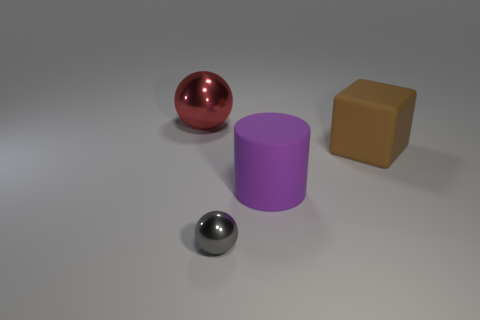What is the color of the metallic thing that is to the right of the shiny ball that is behind the rubber thing that is left of the rubber block?
Provide a succinct answer. Gray. What number of big cubes are the same color as the big metallic object?
Your answer should be compact. 0. What number of small things are red spheres or gray spheres?
Provide a short and direct response. 1. Is there a small metallic thing of the same shape as the big brown matte object?
Provide a short and direct response. No. Is the big red metallic object the same shape as the brown rubber thing?
Your answer should be compact. No. There is a big object that is on the left side of the gray object right of the large metallic sphere; what is its color?
Provide a short and direct response. Red. There is a matte thing that is the same size as the rubber cylinder; what color is it?
Make the answer very short. Brown. How many rubber things are large brown spheres or large cylinders?
Your response must be concise. 1. How many blocks are behind the large object in front of the large brown object?
Your response must be concise. 1. How many objects are either red balls or big objects that are on the left side of the tiny metal thing?
Offer a very short reply. 1. 